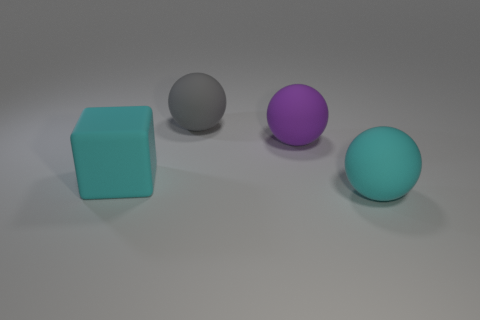Subtract all brown spheres. Subtract all blue cubes. How many spheres are left? 3 Add 3 tiny gray balls. How many objects exist? 7 Subtract all blocks. How many objects are left? 3 Subtract 0 brown blocks. How many objects are left? 4 Subtract all large blue things. Subtract all large gray matte objects. How many objects are left? 3 Add 4 big cyan spheres. How many big cyan spheres are left? 5 Add 4 large gray spheres. How many large gray spheres exist? 5 